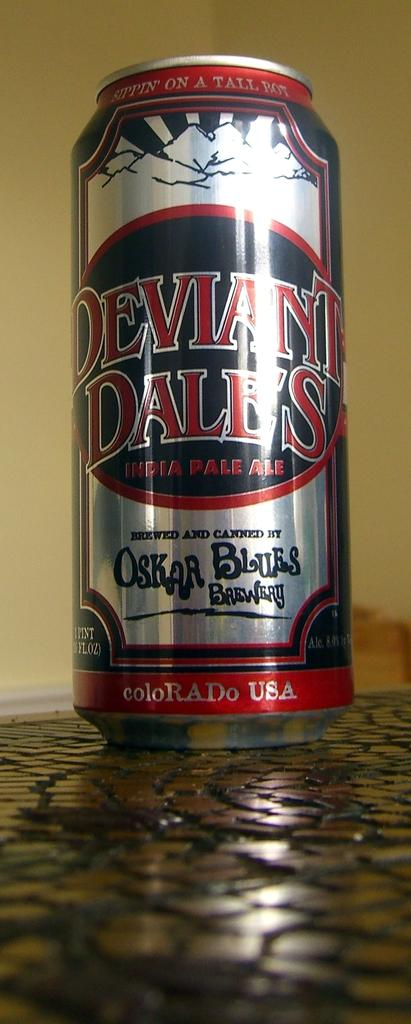<image>
Share a concise interpretation of the image provided. A can of Deviant Dale's India Pale Ale 